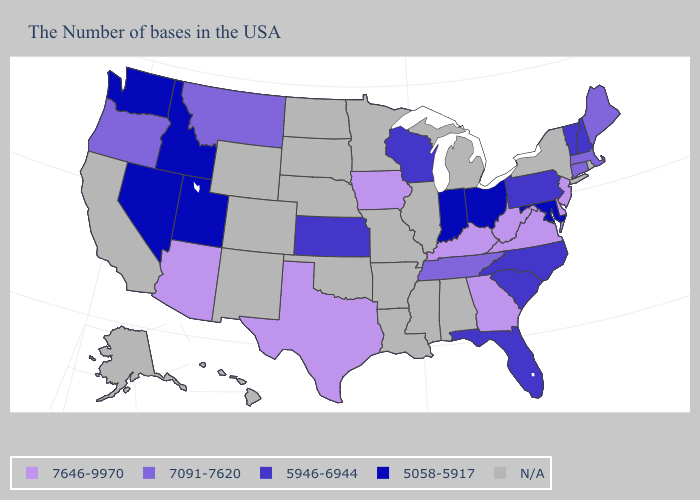What is the value of Pennsylvania?
Concise answer only. 5946-6944. What is the highest value in the USA?
Concise answer only. 7646-9970. Does Georgia have the highest value in the South?
Concise answer only. Yes. How many symbols are there in the legend?
Quick response, please. 5. What is the value of Hawaii?
Answer briefly. N/A. What is the value of Oklahoma?
Keep it brief. N/A. Does Maryland have the highest value in the USA?
Keep it brief. No. Is the legend a continuous bar?
Quick response, please. No. What is the value of California?
Be succinct. N/A. Does the map have missing data?
Short answer required. Yes. Name the states that have a value in the range 7091-7620?
Quick response, please. Maine, Massachusetts, Connecticut, Tennessee, Montana, Oregon. What is the value of Arkansas?
Concise answer only. N/A. Name the states that have a value in the range 7646-9970?
Answer briefly. New Jersey, Delaware, Virginia, West Virginia, Georgia, Kentucky, Iowa, Texas, Arizona. What is the value of Mississippi?
Keep it brief. N/A. 